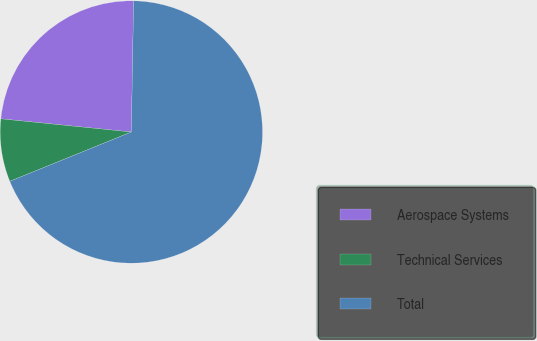Convert chart to OTSL. <chart><loc_0><loc_0><loc_500><loc_500><pie_chart><fcel>Aerospace Systems<fcel>Technical Services<fcel>Total<nl><fcel>23.67%<fcel>7.74%<fcel>68.59%<nl></chart> 